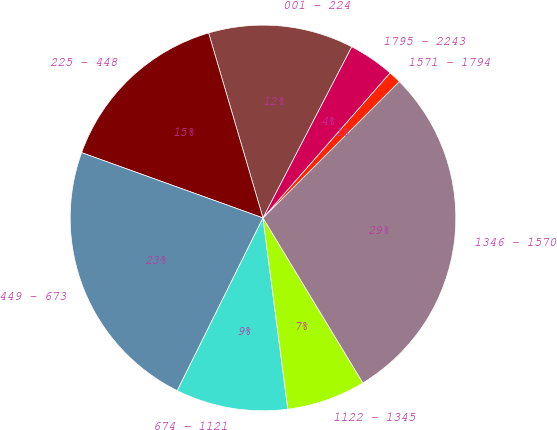<chart> <loc_0><loc_0><loc_500><loc_500><pie_chart><fcel>001 - 224<fcel>225 - 448<fcel>449 - 673<fcel>674 - 1121<fcel>1122 - 1345<fcel>1346 - 1570<fcel>1571 - 1794<fcel>1795 - 2243<nl><fcel>12.17%<fcel>14.95%<fcel>23.17%<fcel>9.39%<fcel>6.61%<fcel>28.84%<fcel>1.05%<fcel>3.83%<nl></chart> 